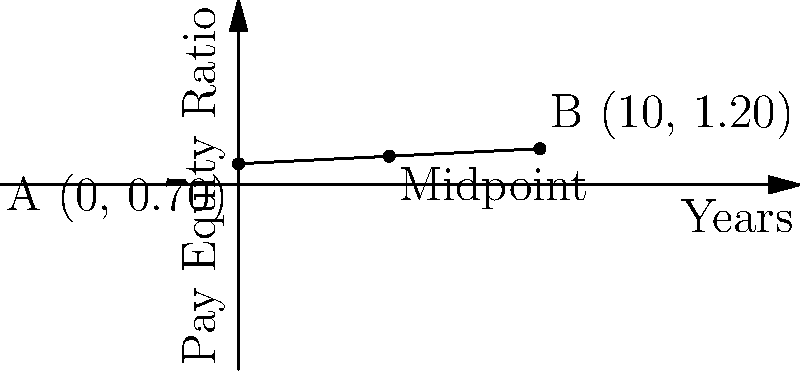In a graph showing gender pay equity progress over time, point A represents the starting point (0 years, 0.70 ratio) and point B represents the end point (10 years, 1.20 ratio). What are the coordinates of the midpoint between these two points, and what does this midpoint represent in terms of pay equity progress? To find the midpoint between two points, we use the midpoint formula:

$$ \text{Midpoint} = (\frac{x_1 + x_2}{2}, \frac{y_1 + y_2}{2}) $$

Where $(x_1, y_1)$ is the first point and $(x_2, y_2)$ is the second point.

1. Identify the coordinates:
   Point A: $(0, 0.70)$
   Point B: $(10, 1.20)$

2. Apply the midpoint formula:
   $x$ coordinate: $\frac{0 + 10}{2} = 5$
   $y$ coordinate: $\frac{0.70 + 1.20}{2} = 0.95$

3. The midpoint coordinates are $(5, 0.95)$

This midpoint represents:
- The point halfway through the 10-year period (5 years)
- The pay equity ratio achieved after 5 years
- The average progress made in closing the gender pay gap over the entire period

For diversity and inclusion strategies, this midpoint can be used to:
- Evaluate the rate of progress in achieving pay equity
- Set intermediate goals for organizations
- Assess if the progress is linear or if there are periods of acceleration or deceleration
Answer: (5, 0.95); represents halfway point in time and progress towards pay equity 